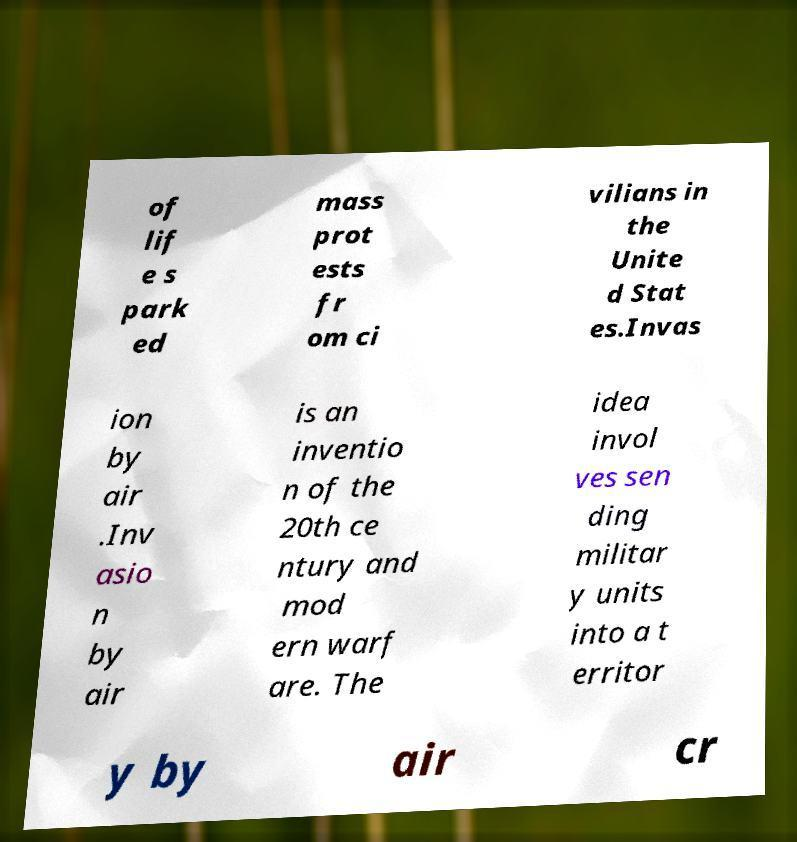Can you read and provide the text displayed in the image?This photo seems to have some interesting text. Can you extract and type it out for me? of lif e s park ed mass prot ests fr om ci vilians in the Unite d Stat es.Invas ion by air .Inv asio n by air is an inventio n of the 20th ce ntury and mod ern warf are. The idea invol ves sen ding militar y units into a t erritor y by air cr 